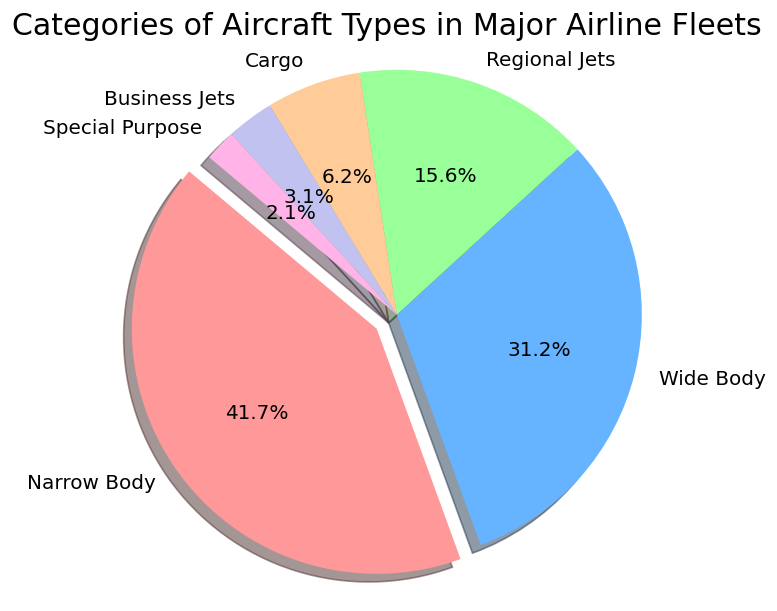What percentage of the fleet is composed of Business Jets? The pie chart section labeled 'Business Jets' shows the percentage directly on the chart.
Answer: 3.0% Which aircraft type has the highest percentage in the airline fleet? The pie chart section with the largest visual area and exploded view is the 'Narrow Body' section.
Answer: Narrow Body By how much does the number of Narrow Body aircraft exceed the number of Regional Jets? Subtract the number of Regional Jets (75) from the number of Narrow Body aircraft (200). 200 - 75 = 125
Answer: 125 What is the total percentage of Cargo and Business Jets combined? Add the percentage from the 'Cargo' section (5.0%) and the 'Business Jets' section (3.0%). 5.0% + 3.0% = 8.0%
Answer: 8.0% Which aircraft type contributes the least to the total number of aircraft? The pie chart section with the smallest visual area is labeled as 'Special Purpose'.
Answer: Special Purpose How does the percentage of Wide Body aircraft compare to Narrow Body aircraft? The pie chart shows the Wide Body at 37.5% and Narrow Body at 50%. Wide Body is less than Narrow Body.
Answer: Less than What is the combined number of Wide Body and Narrow Body aircraft? Add the number of Wide Body (150) and Narrow Body (200) aircraft. 150 + 200 = 350
Answer: 350 What is the difference in the number of Cargo and Special Purpose aircraft? Subtract the number of Special Purpose aircraft (10) from the number of Cargo aircraft (30). 30 - 10 = 20.
Answer: 20 In what color is the 'Regional Jets' section represented? The 'Regional Jets' section is shown in green on the pie chart.
Answer: Green What is the total percentage of the fleet composed of Regional Jets and Wide Body aircraft? Add the percentage of the Regional Jets (12.5%) and Wide Body (37.5%). 12.5% + 37.5% = 50.0%
Answer: 50.0% 